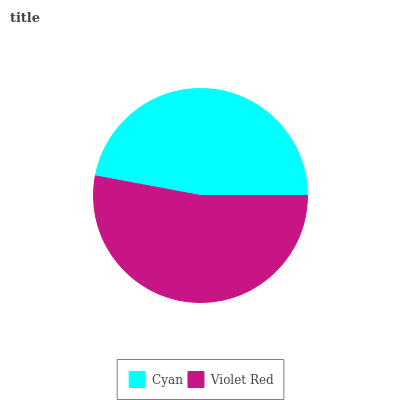Is Cyan the minimum?
Answer yes or no. Yes. Is Violet Red the maximum?
Answer yes or no. Yes. Is Violet Red the minimum?
Answer yes or no. No. Is Violet Red greater than Cyan?
Answer yes or no. Yes. Is Cyan less than Violet Red?
Answer yes or no. Yes. Is Cyan greater than Violet Red?
Answer yes or no. No. Is Violet Red less than Cyan?
Answer yes or no. No. Is Violet Red the high median?
Answer yes or no. Yes. Is Cyan the low median?
Answer yes or no. Yes. Is Cyan the high median?
Answer yes or no. No. Is Violet Red the low median?
Answer yes or no. No. 